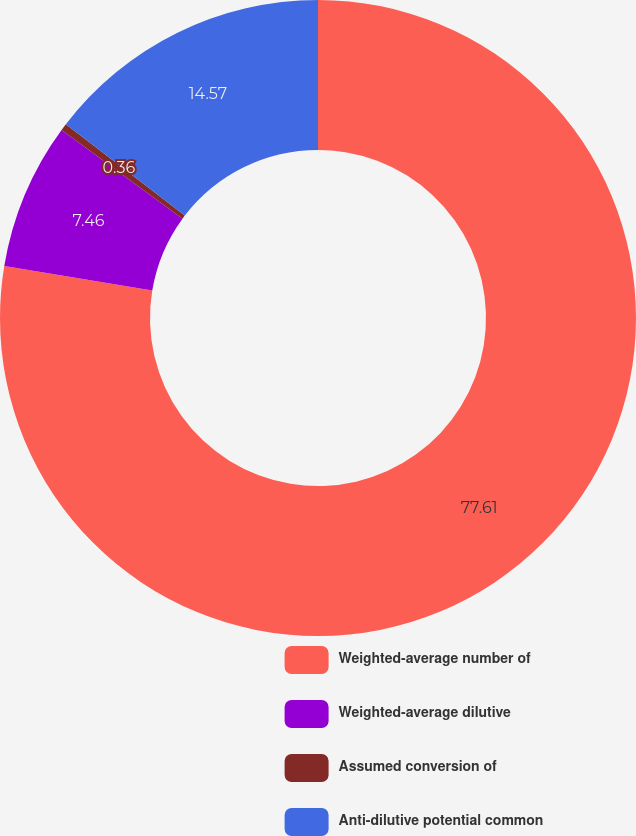Convert chart to OTSL. <chart><loc_0><loc_0><loc_500><loc_500><pie_chart><fcel>Weighted-average number of<fcel>Weighted-average dilutive<fcel>Assumed conversion of<fcel>Anti-dilutive potential common<nl><fcel>77.61%<fcel>7.46%<fcel>0.36%<fcel>14.57%<nl></chart> 